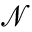<formula> <loc_0><loc_0><loc_500><loc_500>\mathcal { N }</formula> 